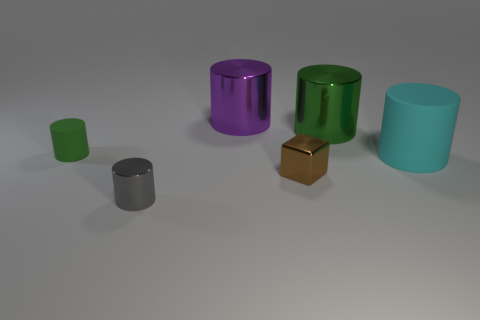There is a big metal thing that is in front of the purple object; is it the same color as the matte object behind the cyan thing?
Make the answer very short. Yes. What color is the small thing that is on the left side of the gray cylinder?
Provide a short and direct response. Green. Do the thing that is to the right of the green metallic cylinder and the tiny shiny block have the same size?
Provide a short and direct response. No. Are there fewer tiny purple balls than cylinders?
Keep it short and to the point. Yes. There is a small block; how many cyan rubber cylinders are right of it?
Provide a succinct answer. 1. Is the big matte object the same shape as the tiny gray metallic object?
Keep it short and to the point. Yes. What number of metal cylinders are both right of the brown thing and in front of the small matte object?
Provide a succinct answer. 0. What number of objects are either big green metal cylinders or cylinders that are to the right of the green matte object?
Provide a short and direct response. 4. Are there more small red matte balls than large matte cylinders?
Keep it short and to the point. No. There is a large metallic thing in front of the purple metallic object; what is its shape?
Your answer should be compact. Cylinder. 